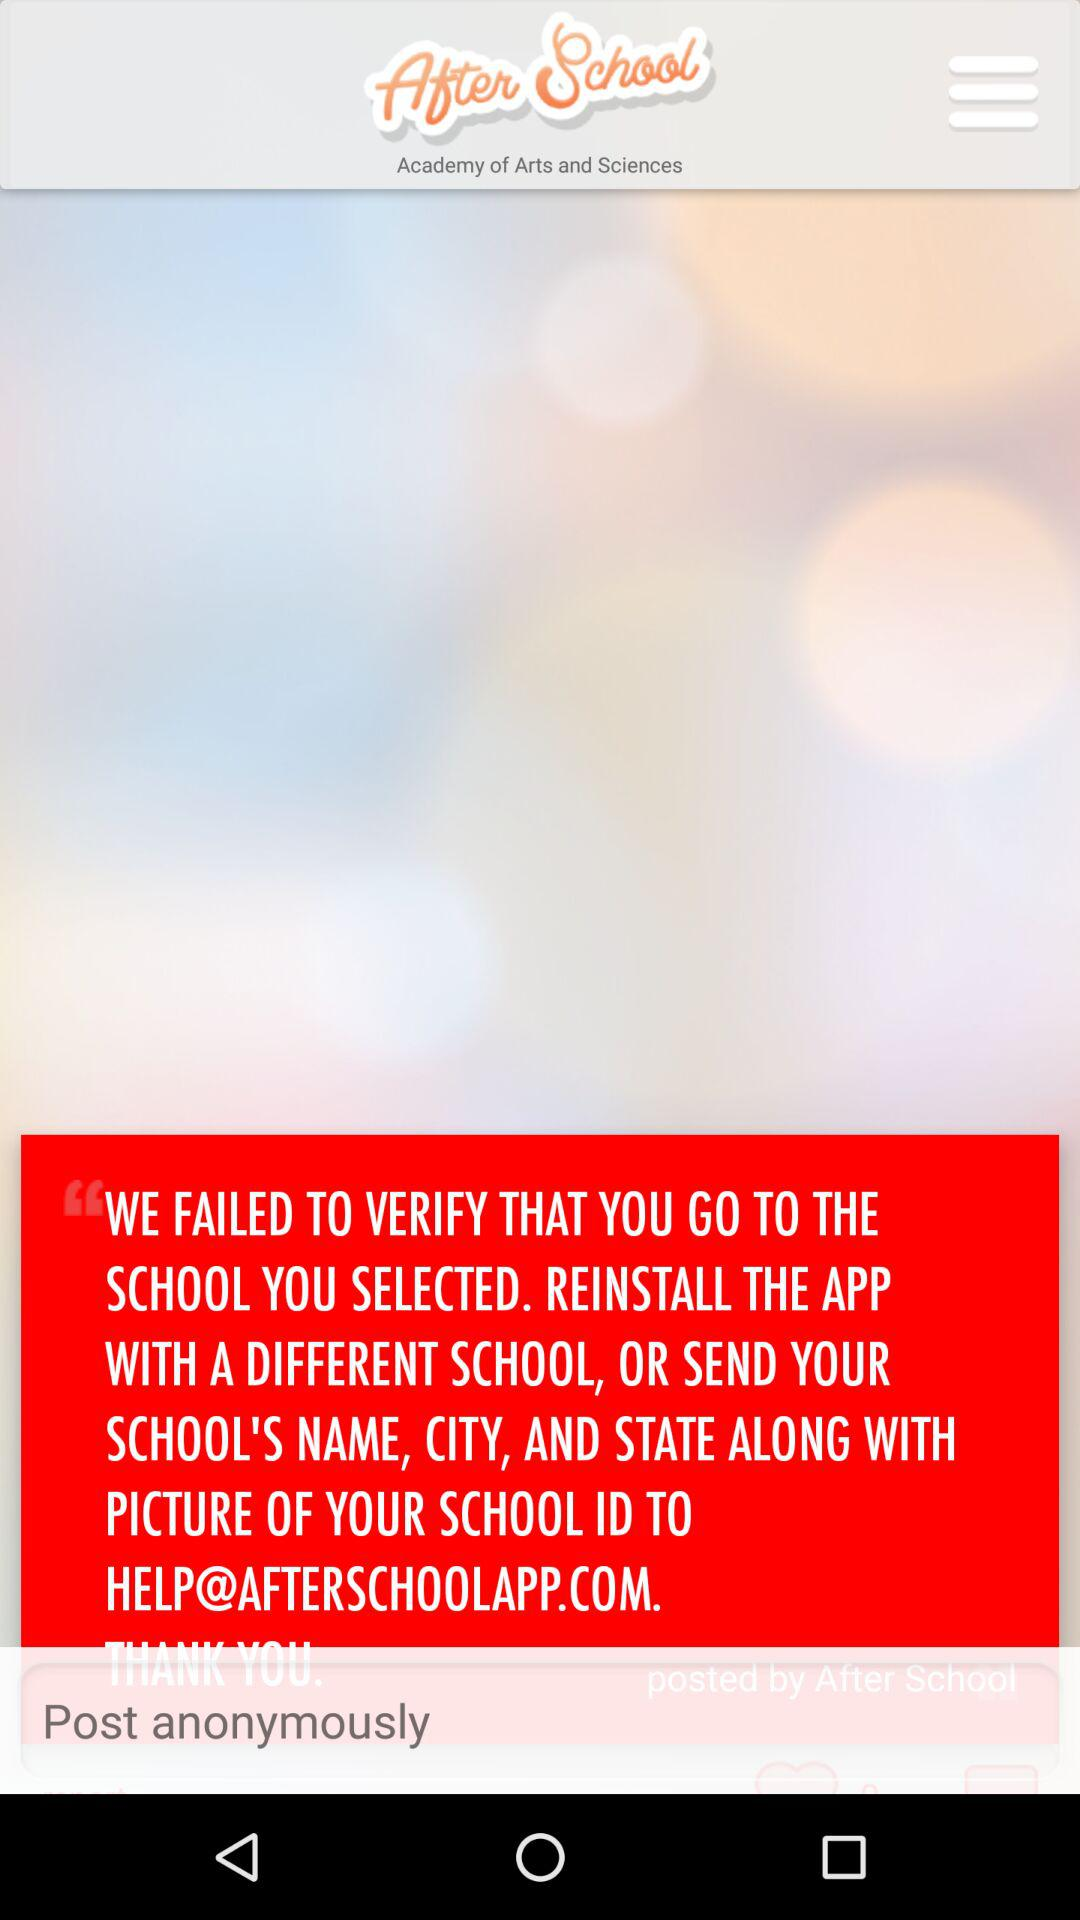What is the version of this application?
When the provided information is insufficient, respond with <no answer>. <no answer> 